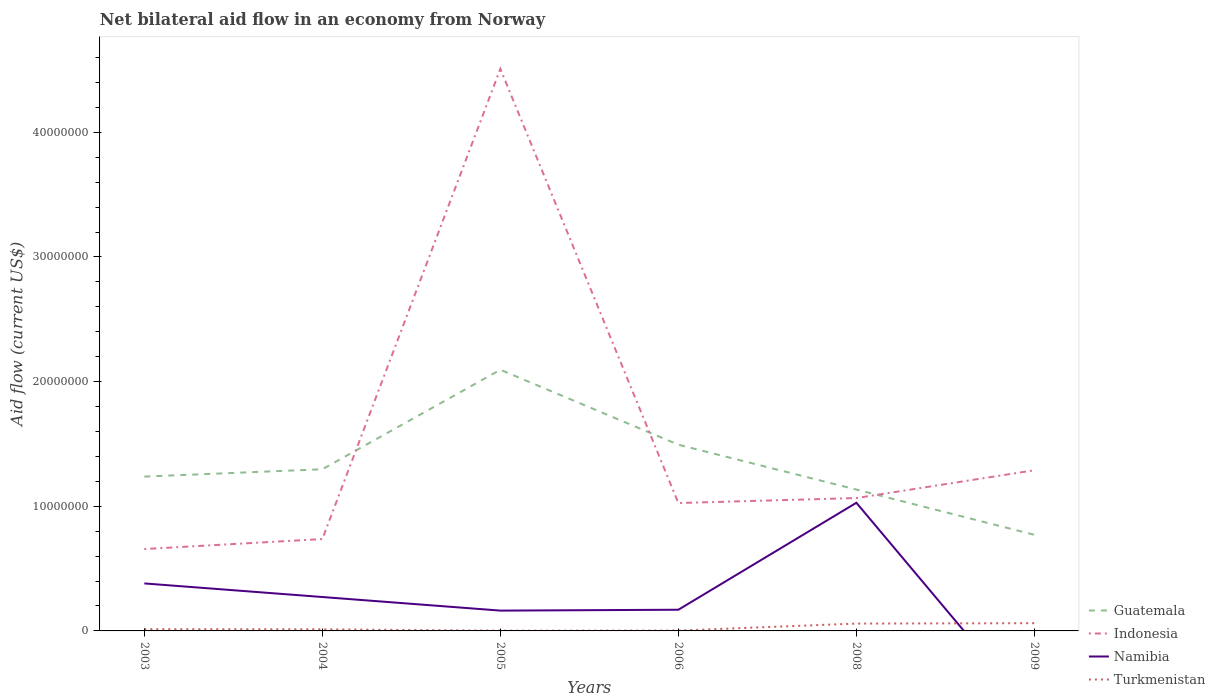Is the number of lines equal to the number of legend labels?
Offer a very short reply. No. Across all years, what is the maximum net bilateral aid flow in Indonesia?
Offer a very short reply. 6.57e+06. What is the total net bilateral aid flow in Turkmenistan in the graph?
Ensure brevity in your answer.  10000. What is the difference between the highest and the second highest net bilateral aid flow in Indonesia?
Offer a terse response. 3.85e+07. Is the net bilateral aid flow in Namibia strictly greater than the net bilateral aid flow in Indonesia over the years?
Provide a succinct answer. Yes. How many lines are there?
Offer a very short reply. 4. How many years are there in the graph?
Offer a very short reply. 6. What is the difference between two consecutive major ticks on the Y-axis?
Give a very brief answer. 1.00e+07. Are the values on the major ticks of Y-axis written in scientific E-notation?
Provide a short and direct response. No. Does the graph contain any zero values?
Offer a terse response. Yes. Where does the legend appear in the graph?
Your answer should be very brief. Bottom right. How many legend labels are there?
Keep it short and to the point. 4. How are the legend labels stacked?
Your answer should be very brief. Vertical. What is the title of the graph?
Ensure brevity in your answer.  Net bilateral aid flow in an economy from Norway. Does "Kenya" appear as one of the legend labels in the graph?
Provide a short and direct response. No. What is the label or title of the Y-axis?
Your answer should be compact. Aid flow (current US$). What is the Aid flow (current US$) of Guatemala in 2003?
Ensure brevity in your answer.  1.24e+07. What is the Aid flow (current US$) of Indonesia in 2003?
Make the answer very short. 6.57e+06. What is the Aid flow (current US$) of Namibia in 2003?
Keep it short and to the point. 3.81e+06. What is the Aid flow (current US$) in Turkmenistan in 2003?
Your response must be concise. 1.40e+05. What is the Aid flow (current US$) of Guatemala in 2004?
Make the answer very short. 1.30e+07. What is the Aid flow (current US$) in Indonesia in 2004?
Make the answer very short. 7.37e+06. What is the Aid flow (current US$) in Namibia in 2004?
Your response must be concise. 2.72e+06. What is the Aid flow (current US$) in Guatemala in 2005?
Provide a short and direct response. 2.10e+07. What is the Aid flow (current US$) of Indonesia in 2005?
Offer a terse response. 4.51e+07. What is the Aid flow (current US$) of Namibia in 2005?
Your answer should be compact. 1.63e+06. What is the Aid flow (current US$) of Guatemala in 2006?
Ensure brevity in your answer.  1.49e+07. What is the Aid flow (current US$) in Indonesia in 2006?
Make the answer very short. 1.03e+07. What is the Aid flow (current US$) in Namibia in 2006?
Provide a short and direct response. 1.70e+06. What is the Aid flow (current US$) of Turkmenistan in 2006?
Give a very brief answer. 3.00e+04. What is the Aid flow (current US$) of Guatemala in 2008?
Provide a succinct answer. 1.13e+07. What is the Aid flow (current US$) in Indonesia in 2008?
Provide a short and direct response. 1.07e+07. What is the Aid flow (current US$) of Namibia in 2008?
Ensure brevity in your answer.  1.03e+07. What is the Aid flow (current US$) in Turkmenistan in 2008?
Offer a very short reply. 5.90e+05. What is the Aid flow (current US$) of Guatemala in 2009?
Your response must be concise. 7.71e+06. What is the Aid flow (current US$) of Indonesia in 2009?
Provide a short and direct response. 1.29e+07. What is the Aid flow (current US$) in Namibia in 2009?
Offer a terse response. 0. What is the Aid flow (current US$) in Turkmenistan in 2009?
Offer a very short reply. 6.20e+05. Across all years, what is the maximum Aid flow (current US$) of Guatemala?
Your answer should be very brief. 2.10e+07. Across all years, what is the maximum Aid flow (current US$) of Indonesia?
Make the answer very short. 4.51e+07. Across all years, what is the maximum Aid flow (current US$) of Namibia?
Offer a terse response. 1.03e+07. Across all years, what is the maximum Aid flow (current US$) of Turkmenistan?
Offer a terse response. 6.20e+05. Across all years, what is the minimum Aid flow (current US$) of Guatemala?
Provide a succinct answer. 7.71e+06. Across all years, what is the minimum Aid flow (current US$) of Indonesia?
Your answer should be very brief. 6.57e+06. Across all years, what is the minimum Aid flow (current US$) of Namibia?
Make the answer very short. 0. Across all years, what is the minimum Aid flow (current US$) of Turkmenistan?
Give a very brief answer. 2.00e+04. What is the total Aid flow (current US$) of Guatemala in the graph?
Provide a succinct answer. 8.03e+07. What is the total Aid flow (current US$) of Indonesia in the graph?
Give a very brief answer. 9.28e+07. What is the total Aid flow (current US$) in Namibia in the graph?
Your answer should be compact. 2.01e+07. What is the total Aid flow (current US$) in Turkmenistan in the graph?
Provide a short and direct response. 1.53e+06. What is the difference between the Aid flow (current US$) of Guatemala in 2003 and that in 2004?
Offer a very short reply. -5.90e+05. What is the difference between the Aid flow (current US$) in Indonesia in 2003 and that in 2004?
Make the answer very short. -8.00e+05. What is the difference between the Aid flow (current US$) of Namibia in 2003 and that in 2004?
Your response must be concise. 1.09e+06. What is the difference between the Aid flow (current US$) in Turkmenistan in 2003 and that in 2004?
Ensure brevity in your answer.  10000. What is the difference between the Aid flow (current US$) of Guatemala in 2003 and that in 2005?
Provide a succinct answer. -8.57e+06. What is the difference between the Aid flow (current US$) of Indonesia in 2003 and that in 2005?
Your answer should be compact. -3.85e+07. What is the difference between the Aid flow (current US$) of Namibia in 2003 and that in 2005?
Offer a terse response. 2.18e+06. What is the difference between the Aid flow (current US$) in Guatemala in 2003 and that in 2006?
Offer a very short reply. -2.56e+06. What is the difference between the Aid flow (current US$) of Indonesia in 2003 and that in 2006?
Make the answer very short. -3.69e+06. What is the difference between the Aid flow (current US$) of Namibia in 2003 and that in 2006?
Keep it short and to the point. 2.11e+06. What is the difference between the Aid flow (current US$) of Guatemala in 2003 and that in 2008?
Provide a short and direct response. 1.04e+06. What is the difference between the Aid flow (current US$) of Indonesia in 2003 and that in 2008?
Keep it short and to the point. -4.09e+06. What is the difference between the Aid flow (current US$) of Namibia in 2003 and that in 2008?
Provide a short and direct response. -6.47e+06. What is the difference between the Aid flow (current US$) of Turkmenistan in 2003 and that in 2008?
Give a very brief answer. -4.50e+05. What is the difference between the Aid flow (current US$) in Guatemala in 2003 and that in 2009?
Keep it short and to the point. 4.67e+06. What is the difference between the Aid flow (current US$) of Indonesia in 2003 and that in 2009?
Make the answer very short. -6.32e+06. What is the difference between the Aid flow (current US$) in Turkmenistan in 2003 and that in 2009?
Ensure brevity in your answer.  -4.80e+05. What is the difference between the Aid flow (current US$) of Guatemala in 2004 and that in 2005?
Ensure brevity in your answer.  -7.98e+06. What is the difference between the Aid flow (current US$) of Indonesia in 2004 and that in 2005?
Offer a very short reply. -3.77e+07. What is the difference between the Aid flow (current US$) in Namibia in 2004 and that in 2005?
Make the answer very short. 1.09e+06. What is the difference between the Aid flow (current US$) in Turkmenistan in 2004 and that in 2005?
Keep it short and to the point. 1.10e+05. What is the difference between the Aid flow (current US$) in Guatemala in 2004 and that in 2006?
Make the answer very short. -1.97e+06. What is the difference between the Aid flow (current US$) in Indonesia in 2004 and that in 2006?
Ensure brevity in your answer.  -2.89e+06. What is the difference between the Aid flow (current US$) in Namibia in 2004 and that in 2006?
Give a very brief answer. 1.02e+06. What is the difference between the Aid flow (current US$) of Turkmenistan in 2004 and that in 2006?
Keep it short and to the point. 1.00e+05. What is the difference between the Aid flow (current US$) in Guatemala in 2004 and that in 2008?
Make the answer very short. 1.63e+06. What is the difference between the Aid flow (current US$) of Indonesia in 2004 and that in 2008?
Your answer should be very brief. -3.29e+06. What is the difference between the Aid flow (current US$) in Namibia in 2004 and that in 2008?
Ensure brevity in your answer.  -7.56e+06. What is the difference between the Aid flow (current US$) of Turkmenistan in 2004 and that in 2008?
Keep it short and to the point. -4.60e+05. What is the difference between the Aid flow (current US$) in Guatemala in 2004 and that in 2009?
Make the answer very short. 5.26e+06. What is the difference between the Aid flow (current US$) of Indonesia in 2004 and that in 2009?
Ensure brevity in your answer.  -5.52e+06. What is the difference between the Aid flow (current US$) in Turkmenistan in 2004 and that in 2009?
Your answer should be compact. -4.90e+05. What is the difference between the Aid flow (current US$) of Guatemala in 2005 and that in 2006?
Offer a terse response. 6.01e+06. What is the difference between the Aid flow (current US$) of Indonesia in 2005 and that in 2006?
Ensure brevity in your answer.  3.48e+07. What is the difference between the Aid flow (current US$) in Namibia in 2005 and that in 2006?
Make the answer very short. -7.00e+04. What is the difference between the Aid flow (current US$) in Guatemala in 2005 and that in 2008?
Keep it short and to the point. 9.61e+06. What is the difference between the Aid flow (current US$) of Indonesia in 2005 and that in 2008?
Give a very brief answer. 3.44e+07. What is the difference between the Aid flow (current US$) of Namibia in 2005 and that in 2008?
Provide a succinct answer. -8.65e+06. What is the difference between the Aid flow (current US$) in Turkmenistan in 2005 and that in 2008?
Give a very brief answer. -5.70e+05. What is the difference between the Aid flow (current US$) in Guatemala in 2005 and that in 2009?
Offer a very short reply. 1.32e+07. What is the difference between the Aid flow (current US$) in Indonesia in 2005 and that in 2009?
Provide a succinct answer. 3.22e+07. What is the difference between the Aid flow (current US$) of Turkmenistan in 2005 and that in 2009?
Offer a very short reply. -6.00e+05. What is the difference between the Aid flow (current US$) of Guatemala in 2006 and that in 2008?
Keep it short and to the point. 3.60e+06. What is the difference between the Aid flow (current US$) of Indonesia in 2006 and that in 2008?
Offer a very short reply. -4.00e+05. What is the difference between the Aid flow (current US$) in Namibia in 2006 and that in 2008?
Offer a very short reply. -8.58e+06. What is the difference between the Aid flow (current US$) of Turkmenistan in 2006 and that in 2008?
Your response must be concise. -5.60e+05. What is the difference between the Aid flow (current US$) in Guatemala in 2006 and that in 2009?
Keep it short and to the point. 7.23e+06. What is the difference between the Aid flow (current US$) in Indonesia in 2006 and that in 2009?
Your answer should be very brief. -2.63e+06. What is the difference between the Aid flow (current US$) in Turkmenistan in 2006 and that in 2009?
Ensure brevity in your answer.  -5.90e+05. What is the difference between the Aid flow (current US$) in Guatemala in 2008 and that in 2009?
Give a very brief answer. 3.63e+06. What is the difference between the Aid flow (current US$) of Indonesia in 2008 and that in 2009?
Make the answer very short. -2.23e+06. What is the difference between the Aid flow (current US$) in Guatemala in 2003 and the Aid flow (current US$) in Indonesia in 2004?
Keep it short and to the point. 5.01e+06. What is the difference between the Aid flow (current US$) of Guatemala in 2003 and the Aid flow (current US$) of Namibia in 2004?
Offer a terse response. 9.66e+06. What is the difference between the Aid flow (current US$) in Guatemala in 2003 and the Aid flow (current US$) in Turkmenistan in 2004?
Your response must be concise. 1.22e+07. What is the difference between the Aid flow (current US$) of Indonesia in 2003 and the Aid flow (current US$) of Namibia in 2004?
Your answer should be very brief. 3.85e+06. What is the difference between the Aid flow (current US$) of Indonesia in 2003 and the Aid flow (current US$) of Turkmenistan in 2004?
Offer a very short reply. 6.44e+06. What is the difference between the Aid flow (current US$) in Namibia in 2003 and the Aid flow (current US$) in Turkmenistan in 2004?
Give a very brief answer. 3.68e+06. What is the difference between the Aid flow (current US$) in Guatemala in 2003 and the Aid flow (current US$) in Indonesia in 2005?
Offer a terse response. -3.27e+07. What is the difference between the Aid flow (current US$) of Guatemala in 2003 and the Aid flow (current US$) of Namibia in 2005?
Give a very brief answer. 1.08e+07. What is the difference between the Aid flow (current US$) of Guatemala in 2003 and the Aid flow (current US$) of Turkmenistan in 2005?
Offer a terse response. 1.24e+07. What is the difference between the Aid flow (current US$) of Indonesia in 2003 and the Aid flow (current US$) of Namibia in 2005?
Provide a short and direct response. 4.94e+06. What is the difference between the Aid flow (current US$) of Indonesia in 2003 and the Aid flow (current US$) of Turkmenistan in 2005?
Provide a succinct answer. 6.55e+06. What is the difference between the Aid flow (current US$) in Namibia in 2003 and the Aid flow (current US$) in Turkmenistan in 2005?
Make the answer very short. 3.79e+06. What is the difference between the Aid flow (current US$) of Guatemala in 2003 and the Aid flow (current US$) of Indonesia in 2006?
Keep it short and to the point. 2.12e+06. What is the difference between the Aid flow (current US$) of Guatemala in 2003 and the Aid flow (current US$) of Namibia in 2006?
Offer a very short reply. 1.07e+07. What is the difference between the Aid flow (current US$) in Guatemala in 2003 and the Aid flow (current US$) in Turkmenistan in 2006?
Ensure brevity in your answer.  1.24e+07. What is the difference between the Aid flow (current US$) of Indonesia in 2003 and the Aid flow (current US$) of Namibia in 2006?
Make the answer very short. 4.87e+06. What is the difference between the Aid flow (current US$) in Indonesia in 2003 and the Aid flow (current US$) in Turkmenistan in 2006?
Give a very brief answer. 6.54e+06. What is the difference between the Aid flow (current US$) of Namibia in 2003 and the Aid flow (current US$) of Turkmenistan in 2006?
Make the answer very short. 3.78e+06. What is the difference between the Aid flow (current US$) of Guatemala in 2003 and the Aid flow (current US$) of Indonesia in 2008?
Keep it short and to the point. 1.72e+06. What is the difference between the Aid flow (current US$) in Guatemala in 2003 and the Aid flow (current US$) in Namibia in 2008?
Your response must be concise. 2.10e+06. What is the difference between the Aid flow (current US$) in Guatemala in 2003 and the Aid flow (current US$) in Turkmenistan in 2008?
Provide a succinct answer. 1.18e+07. What is the difference between the Aid flow (current US$) of Indonesia in 2003 and the Aid flow (current US$) of Namibia in 2008?
Your answer should be compact. -3.71e+06. What is the difference between the Aid flow (current US$) in Indonesia in 2003 and the Aid flow (current US$) in Turkmenistan in 2008?
Give a very brief answer. 5.98e+06. What is the difference between the Aid flow (current US$) of Namibia in 2003 and the Aid flow (current US$) of Turkmenistan in 2008?
Give a very brief answer. 3.22e+06. What is the difference between the Aid flow (current US$) in Guatemala in 2003 and the Aid flow (current US$) in Indonesia in 2009?
Offer a very short reply. -5.10e+05. What is the difference between the Aid flow (current US$) of Guatemala in 2003 and the Aid flow (current US$) of Turkmenistan in 2009?
Ensure brevity in your answer.  1.18e+07. What is the difference between the Aid flow (current US$) in Indonesia in 2003 and the Aid flow (current US$) in Turkmenistan in 2009?
Your response must be concise. 5.95e+06. What is the difference between the Aid flow (current US$) of Namibia in 2003 and the Aid flow (current US$) of Turkmenistan in 2009?
Offer a terse response. 3.19e+06. What is the difference between the Aid flow (current US$) in Guatemala in 2004 and the Aid flow (current US$) in Indonesia in 2005?
Make the answer very short. -3.21e+07. What is the difference between the Aid flow (current US$) of Guatemala in 2004 and the Aid flow (current US$) of Namibia in 2005?
Offer a very short reply. 1.13e+07. What is the difference between the Aid flow (current US$) in Guatemala in 2004 and the Aid flow (current US$) in Turkmenistan in 2005?
Offer a terse response. 1.30e+07. What is the difference between the Aid flow (current US$) of Indonesia in 2004 and the Aid flow (current US$) of Namibia in 2005?
Your response must be concise. 5.74e+06. What is the difference between the Aid flow (current US$) in Indonesia in 2004 and the Aid flow (current US$) in Turkmenistan in 2005?
Provide a succinct answer. 7.35e+06. What is the difference between the Aid flow (current US$) of Namibia in 2004 and the Aid flow (current US$) of Turkmenistan in 2005?
Your response must be concise. 2.70e+06. What is the difference between the Aid flow (current US$) of Guatemala in 2004 and the Aid flow (current US$) of Indonesia in 2006?
Your answer should be very brief. 2.71e+06. What is the difference between the Aid flow (current US$) of Guatemala in 2004 and the Aid flow (current US$) of Namibia in 2006?
Make the answer very short. 1.13e+07. What is the difference between the Aid flow (current US$) of Guatemala in 2004 and the Aid flow (current US$) of Turkmenistan in 2006?
Provide a short and direct response. 1.29e+07. What is the difference between the Aid flow (current US$) of Indonesia in 2004 and the Aid flow (current US$) of Namibia in 2006?
Ensure brevity in your answer.  5.67e+06. What is the difference between the Aid flow (current US$) in Indonesia in 2004 and the Aid flow (current US$) in Turkmenistan in 2006?
Make the answer very short. 7.34e+06. What is the difference between the Aid flow (current US$) in Namibia in 2004 and the Aid flow (current US$) in Turkmenistan in 2006?
Ensure brevity in your answer.  2.69e+06. What is the difference between the Aid flow (current US$) in Guatemala in 2004 and the Aid flow (current US$) in Indonesia in 2008?
Your answer should be compact. 2.31e+06. What is the difference between the Aid flow (current US$) of Guatemala in 2004 and the Aid flow (current US$) of Namibia in 2008?
Provide a succinct answer. 2.69e+06. What is the difference between the Aid flow (current US$) in Guatemala in 2004 and the Aid flow (current US$) in Turkmenistan in 2008?
Make the answer very short. 1.24e+07. What is the difference between the Aid flow (current US$) in Indonesia in 2004 and the Aid flow (current US$) in Namibia in 2008?
Give a very brief answer. -2.91e+06. What is the difference between the Aid flow (current US$) in Indonesia in 2004 and the Aid flow (current US$) in Turkmenistan in 2008?
Offer a terse response. 6.78e+06. What is the difference between the Aid flow (current US$) of Namibia in 2004 and the Aid flow (current US$) of Turkmenistan in 2008?
Your answer should be very brief. 2.13e+06. What is the difference between the Aid flow (current US$) of Guatemala in 2004 and the Aid flow (current US$) of Indonesia in 2009?
Provide a short and direct response. 8.00e+04. What is the difference between the Aid flow (current US$) in Guatemala in 2004 and the Aid flow (current US$) in Turkmenistan in 2009?
Provide a succinct answer. 1.24e+07. What is the difference between the Aid flow (current US$) of Indonesia in 2004 and the Aid flow (current US$) of Turkmenistan in 2009?
Provide a short and direct response. 6.75e+06. What is the difference between the Aid flow (current US$) of Namibia in 2004 and the Aid flow (current US$) of Turkmenistan in 2009?
Make the answer very short. 2.10e+06. What is the difference between the Aid flow (current US$) in Guatemala in 2005 and the Aid flow (current US$) in Indonesia in 2006?
Offer a very short reply. 1.07e+07. What is the difference between the Aid flow (current US$) of Guatemala in 2005 and the Aid flow (current US$) of Namibia in 2006?
Your answer should be very brief. 1.92e+07. What is the difference between the Aid flow (current US$) of Guatemala in 2005 and the Aid flow (current US$) of Turkmenistan in 2006?
Make the answer very short. 2.09e+07. What is the difference between the Aid flow (current US$) of Indonesia in 2005 and the Aid flow (current US$) of Namibia in 2006?
Give a very brief answer. 4.34e+07. What is the difference between the Aid flow (current US$) in Indonesia in 2005 and the Aid flow (current US$) in Turkmenistan in 2006?
Provide a short and direct response. 4.51e+07. What is the difference between the Aid flow (current US$) of Namibia in 2005 and the Aid flow (current US$) of Turkmenistan in 2006?
Your answer should be very brief. 1.60e+06. What is the difference between the Aid flow (current US$) of Guatemala in 2005 and the Aid flow (current US$) of Indonesia in 2008?
Your answer should be very brief. 1.03e+07. What is the difference between the Aid flow (current US$) in Guatemala in 2005 and the Aid flow (current US$) in Namibia in 2008?
Your answer should be very brief. 1.07e+07. What is the difference between the Aid flow (current US$) in Guatemala in 2005 and the Aid flow (current US$) in Turkmenistan in 2008?
Ensure brevity in your answer.  2.04e+07. What is the difference between the Aid flow (current US$) in Indonesia in 2005 and the Aid flow (current US$) in Namibia in 2008?
Your response must be concise. 3.48e+07. What is the difference between the Aid flow (current US$) of Indonesia in 2005 and the Aid flow (current US$) of Turkmenistan in 2008?
Your answer should be compact. 4.45e+07. What is the difference between the Aid flow (current US$) of Namibia in 2005 and the Aid flow (current US$) of Turkmenistan in 2008?
Offer a very short reply. 1.04e+06. What is the difference between the Aid flow (current US$) in Guatemala in 2005 and the Aid flow (current US$) in Indonesia in 2009?
Your answer should be very brief. 8.06e+06. What is the difference between the Aid flow (current US$) in Guatemala in 2005 and the Aid flow (current US$) in Turkmenistan in 2009?
Give a very brief answer. 2.03e+07. What is the difference between the Aid flow (current US$) of Indonesia in 2005 and the Aid flow (current US$) of Turkmenistan in 2009?
Offer a terse response. 4.45e+07. What is the difference between the Aid flow (current US$) of Namibia in 2005 and the Aid flow (current US$) of Turkmenistan in 2009?
Keep it short and to the point. 1.01e+06. What is the difference between the Aid flow (current US$) of Guatemala in 2006 and the Aid flow (current US$) of Indonesia in 2008?
Offer a terse response. 4.28e+06. What is the difference between the Aid flow (current US$) in Guatemala in 2006 and the Aid flow (current US$) in Namibia in 2008?
Give a very brief answer. 4.66e+06. What is the difference between the Aid flow (current US$) of Guatemala in 2006 and the Aid flow (current US$) of Turkmenistan in 2008?
Provide a short and direct response. 1.44e+07. What is the difference between the Aid flow (current US$) of Indonesia in 2006 and the Aid flow (current US$) of Namibia in 2008?
Provide a succinct answer. -2.00e+04. What is the difference between the Aid flow (current US$) in Indonesia in 2006 and the Aid flow (current US$) in Turkmenistan in 2008?
Your response must be concise. 9.67e+06. What is the difference between the Aid flow (current US$) in Namibia in 2006 and the Aid flow (current US$) in Turkmenistan in 2008?
Give a very brief answer. 1.11e+06. What is the difference between the Aid flow (current US$) in Guatemala in 2006 and the Aid flow (current US$) in Indonesia in 2009?
Your response must be concise. 2.05e+06. What is the difference between the Aid flow (current US$) of Guatemala in 2006 and the Aid flow (current US$) of Turkmenistan in 2009?
Provide a short and direct response. 1.43e+07. What is the difference between the Aid flow (current US$) of Indonesia in 2006 and the Aid flow (current US$) of Turkmenistan in 2009?
Keep it short and to the point. 9.64e+06. What is the difference between the Aid flow (current US$) of Namibia in 2006 and the Aid flow (current US$) of Turkmenistan in 2009?
Provide a short and direct response. 1.08e+06. What is the difference between the Aid flow (current US$) in Guatemala in 2008 and the Aid flow (current US$) in Indonesia in 2009?
Ensure brevity in your answer.  -1.55e+06. What is the difference between the Aid flow (current US$) of Guatemala in 2008 and the Aid flow (current US$) of Turkmenistan in 2009?
Your response must be concise. 1.07e+07. What is the difference between the Aid flow (current US$) in Indonesia in 2008 and the Aid flow (current US$) in Turkmenistan in 2009?
Provide a short and direct response. 1.00e+07. What is the difference between the Aid flow (current US$) in Namibia in 2008 and the Aid flow (current US$) in Turkmenistan in 2009?
Provide a short and direct response. 9.66e+06. What is the average Aid flow (current US$) in Guatemala per year?
Your answer should be very brief. 1.34e+07. What is the average Aid flow (current US$) of Indonesia per year?
Give a very brief answer. 1.55e+07. What is the average Aid flow (current US$) of Namibia per year?
Your answer should be very brief. 3.36e+06. What is the average Aid flow (current US$) of Turkmenistan per year?
Provide a succinct answer. 2.55e+05. In the year 2003, what is the difference between the Aid flow (current US$) of Guatemala and Aid flow (current US$) of Indonesia?
Offer a terse response. 5.81e+06. In the year 2003, what is the difference between the Aid flow (current US$) of Guatemala and Aid flow (current US$) of Namibia?
Provide a short and direct response. 8.57e+06. In the year 2003, what is the difference between the Aid flow (current US$) in Guatemala and Aid flow (current US$) in Turkmenistan?
Ensure brevity in your answer.  1.22e+07. In the year 2003, what is the difference between the Aid flow (current US$) of Indonesia and Aid flow (current US$) of Namibia?
Your answer should be compact. 2.76e+06. In the year 2003, what is the difference between the Aid flow (current US$) in Indonesia and Aid flow (current US$) in Turkmenistan?
Provide a succinct answer. 6.43e+06. In the year 2003, what is the difference between the Aid flow (current US$) of Namibia and Aid flow (current US$) of Turkmenistan?
Your answer should be very brief. 3.67e+06. In the year 2004, what is the difference between the Aid flow (current US$) in Guatemala and Aid flow (current US$) in Indonesia?
Make the answer very short. 5.60e+06. In the year 2004, what is the difference between the Aid flow (current US$) of Guatemala and Aid flow (current US$) of Namibia?
Your answer should be compact. 1.02e+07. In the year 2004, what is the difference between the Aid flow (current US$) in Guatemala and Aid flow (current US$) in Turkmenistan?
Your answer should be very brief. 1.28e+07. In the year 2004, what is the difference between the Aid flow (current US$) of Indonesia and Aid flow (current US$) of Namibia?
Give a very brief answer. 4.65e+06. In the year 2004, what is the difference between the Aid flow (current US$) in Indonesia and Aid flow (current US$) in Turkmenistan?
Ensure brevity in your answer.  7.24e+06. In the year 2004, what is the difference between the Aid flow (current US$) in Namibia and Aid flow (current US$) in Turkmenistan?
Your answer should be very brief. 2.59e+06. In the year 2005, what is the difference between the Aid flow (current US$) in Guatemala and Aid flow (current US$) in Indonesia?
Give a very brief answer. -2.41e+07. In the year 2005, what is the difference between the Aid flow (current US$) in Guatemala and Aid flow (current US$) in Namibia?
Provide a succinct answer. 1.93e+07. In the year 2005, what is the difference between the Aid flow (current US$) of Guatemala and Aid flow (current US$) of Turkmenistan?
Provide a succinct answer. 2.09e+07. In the year 2005, what is the difference between the Aid flow (current US$) in Indonesia and Aid flow (current US$) in Namibia?
Offer a terse response. 4.35e+07. In the year 2005, what is the difference between the Aid flow (current US$) in Indonesia and Aid flow (current US$) in Turkmenistan?
Provide a succinct answer. 4.51e+07. In the year 2005, what is the difference between the Aid flow (current US$) in Namibia and Aid flow (current US$) in Turkmenistan?
Make the answer very short. 1.61e+06. In the year 2006, what is the difference between the Aid flow (current US$) of Guatemala and Aid flow (current US$) of Indonesia?
Your response must be concise. 4.68e+06. In the year 2006, what is the difference between the Aid flow (current US$) of Guatemala and Aid flow (current US$) of Namibia?
Your answer should be compact. 1.32e+07. In the year 2006, what is the difference between the Aid flow (current US$) of Guatemala and Aid flow (current US$) of Turkmenistan?
Offer a terse response. 1.49e+07. In the year 2006, what is the difference between the Aid flow (current US$) of Indonesia and Aid flow (current US$) of Namibia?
Provide a succinct answer. 8.56e+06. In the year 2006, what is the difference between the Aid flow (current US$) in Indonesia and Aid flow (current US$) in Turkmenistan?
Offer a very short reply. 1.02e+07. In the year 2006, what is the difference between the Aid flow (current US$) in Namibia and Aid flow (current US$) in Turkmenistan?
Give a very brief answer. 1.67e+06. In the year 2008, what is the difference between the Aid flow (current US$) in Guatemala and Aid flow (current US$) in Indonesia?
Make the answer very short. 6.80e+05. In the year 2008, what is the difference between the Aid flow (current US$) in Guatemala and Aid flow (current US$) in Namibia?
Offer a very short reply. 1.06e+06. In the year 2008, what is the difference between the Aid flow (current US$) in Guatemala and Aid flow (current US$) in Turkmenistan?
Your answer should be very brief. 1.08e+07. In the year 2008, what is the difference between the Aid flow (current US$) in Indonesia and Aid flow (current US$) in Namibia?
Your response must be concise. 3.80e+05. In the year 2008, what is the difference between the Aid flow (current US$) of Indonesia and Aid flow (current US$) of Turkmenistan?
Give a very brief answer. 1.01e+07. In the year 2008, what is the difference between the Aid flow (current US$) of Namibia and Aid flow (current US$) of Turkmenistan?
Your answer should be very brief. 9.69e+06. In the year 2009, what is the difference between the Aid flow (current US$) of Guatemala and Aid flow (current US$) of Indonesia?
Make the answer very short. -5.18e+06. In the year 2009, what is the difference between the Aid flow (current US$) in Guatemala and Aid flow (current US$) in Turkmenistan?
Ensure brevity in your answer.  7.09e+06. In the year 2009, what is the difference between the Aid flow (current US$) in Indonesia and Aid flow (current US$) in Turkmenistan?
Keep it short and to the point. 1.23e+07. What is the ratio of the Aid flow (current US$) in Guatemala in 2003 to that in 2004?
Ensure brevity in your answer.  0.95. What is the ratio of the Aid flow (current US$) of Indonesia in 2003 to that in 2004?
Provide a succinct answer. 0.89. What is the ratio of the Aid flow (current US$) in Namibia in 2003 to that in 2004?
Make the answer very short. 1.4. What is the ratio of the Aid flow (current US$) of Turkmenistan in 2003 to that in 2004?
Make the answer very short. 1.08. What is the ratio of the Aid flow (current US$) of Guatemala in 2003 to that in 2005?
Ensure brevity in your answer.  0.59. What is the ratio of the Aid flow (current US$) in Indonesia in 2003 to that in 2005?
Your answer should be compact. 0.15. What is the ratio of the Aid flow (current US$) in Namibia in 2003 to that in 2005?
Offer a terse response. 2.34. What is the ratio of the Aid flow (current US$) in Guatemala in 2003 to that in 2006?
Offer a terse response. 0.83. What is the ratio of the Aid flow (current US$) of Indonesia in 2003 to that in 2006?
Your answer should be very brief. 0.64. What is the ratio of the Aid flow (current US$) of Namibia in 2003 to that in 2006?
Offer a terse response. 2.24. What is the ratio of the Aid flow (current US$) of Turkmenistan in 2003 to that in 2006?
Offer a very short reply. 4.67. What is the ratio of the Aid flow (current US$) in Guatemala in 2003 to that in 2008?
Ensure brevity in your answer.  1.09. What is the ratio of the Aid flow (current US$) in Indonesia in 2003 to that in 2008?
Your answer should be compact. 0.62. What is the ratio of the Aid flow (current US$) in Namibia in 2003 to that in 2008?
Offer a terse response. 0.37. What is the ratio of the Aid flow (current US$) in Turkmenistan in 2003 to that in 2008?
Your answer should be very brief. 0.24. What is the ratio of the Aid flow (current US$) in Guatemala in 2003 to that in 2009?
Your answer should be very brief. 1.61. What is the ratio of the Aid flow (current US$) in Indonesia in 2003 to that in 2009?
Your answer should be compact. 0.51. What is the ratio of the Aid flow (current US$) in Turkmenistan in 2003 to that in 2009?
Provide a short and direct response. 0.23. What is the ratio of the Aid flow (current US$) in Guatemala in 2004 to that in 2005?
Ensure brevity in your answer.  0.62. What is the ratio of the Aid flow (current US$) in Indonesia in 2004 to that in 2005?
Your answer should be compact. 0.16. What is the ratio of the Aid flow (current US$) in Namibia in 2004 to that in 2005?
Make the answer very short. 1.67. What is the ratio of the Aid flow (current US$) of Turkmenistan in 2004 to that in 2005?
Your response must be concise. 6.5. What is the ratio of the Aid flow (current US$) of Guatemala in 2004 to that in 2006?
Offer a terse response. 0.87. What is the ratio of the Aid flow (current US$) in Indonesia in 2004 to that in 2006?
Provide a short and direct response. 0.72. What is the ratio of the Aid flow (current US$) of Turkmenistan in 2004 to that in 2006?
Give a very brief answer. 4.33. What is the ratio of the Aid flow (current US$) of Guatemala in 2004 to that in 2008?
Offer a terse response. 1.14. What is the ratio of the Aid flow (current US$) of Indonesia in 2004 to that in 2008?
Your response must be concise. 0.69. What is the ratio of the Aid flow (current US$) of Namibia in 2004 to that in 2008?
Your answer should be very brief. 0.26. What is the ratio of the Aid flow (current US$) in Turkmenistan in 2004 to that in 2008?
Your response must be concise. 0.22. What is the ratio of the Aid flow (current US$) in Guatemala in 2004 to that in 2009?
Keep it short and to the point. 1.68. What is the ratio of the Aid flow (current US$) of Indonesia in 2004 to that in 2009?
Offer a very short reply. 0.57. What is the ratio of the Aid flow (current US$) in Turkmenistan in 2004 to that in 2009?
Offer a terse response. 0.21. What is the ratio of the Aid flow (current US$) in Guatemala in 2005 to that in 2006?
Keep it short and to the point. 1.4. What is the ratio of the Aid flow (current US$) of Indonesia in 2005 to that in 2006?
Your answer should be very brief. 4.39. What is the ratio of the Aid flow (current US$) of Namibia in 2005 to that in 2006?
Make the answer very short. 0.96. What is the ratio of the Aid flow (current US$) in Turkmenistan in 2005 to that in 2006?
Offer a terse response. 0.67. What is the ratio of the Aid flow (current US$) of Guatemala in 2005 to that in 2008?
Ensure brevity in your answer.  1.85. What is the ratio of the Aid flow (current US$) of Indonesia in 2005 to that in 2008?
Offer a terse response. 4.23. What is the ratio of the Aid flow (current US$) in Namibia in 2005 to that in 2008?
Your answer should be compact. 0.16. What is the ratio of the Aid flow (current US$) in Turkmenistan in 2005 to that in 2008?
Keep it short and to the point. 0.03. What is the ratio of the Aid flow (current US$) of Guatemala in 2005 to that in 2009?
Offer a terse response. 2.72. What is the ratio of the Aid flow (current US$) of Indonesia in 2005 to that in 2009?
Provide a succinct answer. 3.5. What is the ratio of the Aid flow (current US$) in Turkmenistan in 2005 to that in 2009?
Provide a succinct answer. 0.03. What is the ratio of the Aid flow (current US$) in Guatemala in 2006 to that in 2008?
Give a very brief answer. 1.32. What is the ratio of the Aid flow (current US$) of Indonesia in 2006 to that in 2008?
Your answer should be compact. 0.96. What is the ratio of the Aid flow (current US$) in Namibia in 2006 to that in 2008?
Your response must be concise. 0.17. What is the ratio of the Aid flow (current US$) of Turkmenistan in 2006 to that in 2008?
Keep it short and to the point. 0.05. What is the ratio of the Aid flow (current US$) of Guatemala in 2006 to that in 2009?
Offer a terse response. 1.94. What is the ratio of the Aid flow (current US$) in Indonesia in 2006 to that in 2009?
Give a very brief answer. 0.8. What is the ratio of the Aid flow (current US$) of Turkmenistan in 2006 to that in 2009?
Offer a very short reply. 0.05. What is the ratio of the Aid flow (current US$) of Guatemala in 2008 to that in 2009?
Offer a very short reply. 1.47. What is the ratio of the Aid flow (current US$) of Indonesia in 2008 to that in 2009?
Make the answer very short. 0.83. What is the ratio of the Aid flow (current US$) in Turkmenistan in 2008 to that in 2009?
Give a very brief answer. 0.95. What is the difference between the highest and the second highest Aid flow (current US$) in Guatemala?
Keep it short and to the point. 6.01e+06. What is the difference between the highest and the second highest Aid flow (current US$) of Indonesia?
Provide a short and direct response. 3.22e+07. What is the difference between the highest and the second highest Aid flow (current US$) in Namibia?
Keep it short and to the point. 6.47e+06. What is the difference between the highest and the lowest Aid flow (current US$) in Guatemala?
Offer a terse response. 1.32e+07. What is the difference between the highest and the lowest Aid flow (current US$) in Indonesia?
Offer a terse response. 3.85e+07. What is the difference between the highest and the lowest Aid flow (current US$) of Namibia?
Your answer should be very brief. 1.03e+07. What is the difference between the highest and the lowest Aid flow (current US$) in Turkmenistan?
Your response must be concise. 6.00e+05. 